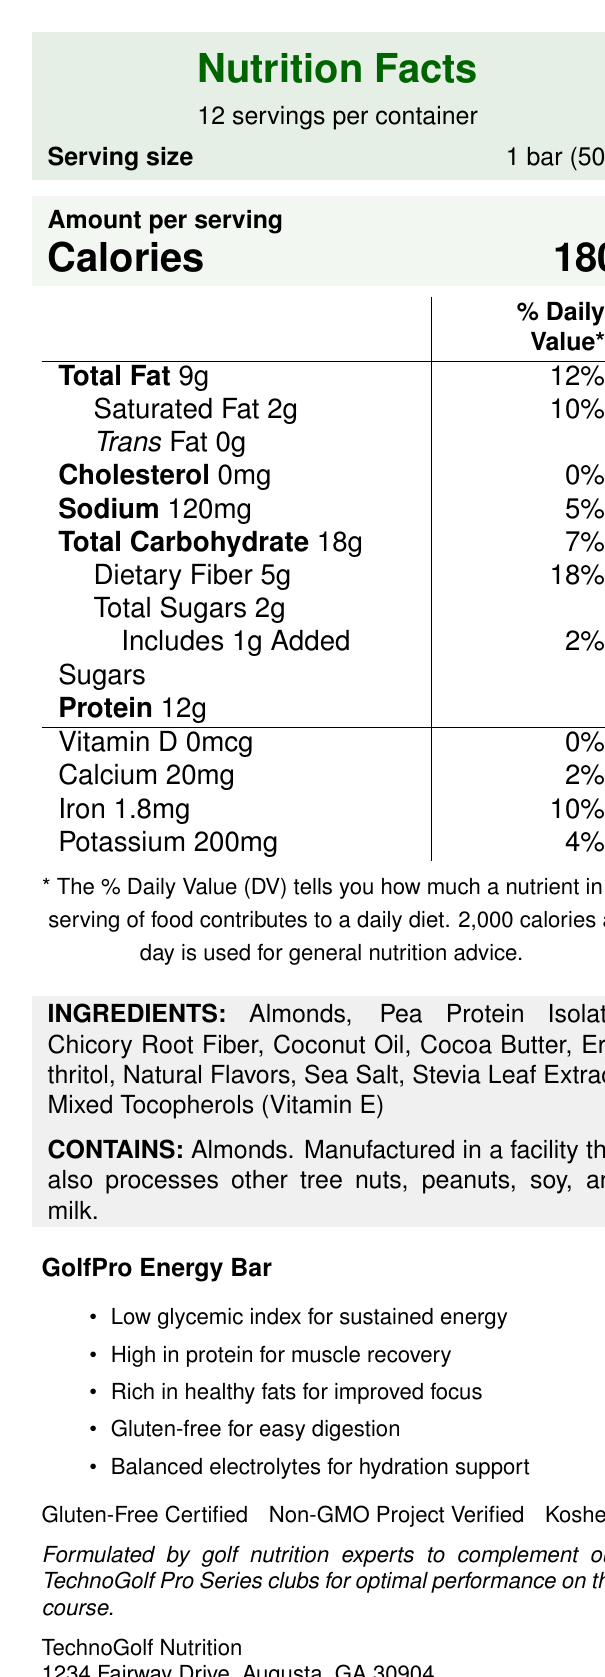What is the serving size of the GolfPro Energy Bar? The serving size is stated as "1 bar (50g)" under the Nutrition Facts.
Answer: 1 bar (50g) How many calories are in one serving of the GolfPro Energy Bar? The document specifies the calorie content per serving as 180.
Answer: 180 What percentage of the Daily Value is the total fat content per serving? The document states that the total fat content per serving is 12% of the Daily Value.
Answer: 12% Which ingredient provides dietary fiber in the GolfPro Energy Bar? Chicory Root Fiber is listed among the ingredients and is known for its high fiber content.
Answer: Chicory Root Fiber How much protein does one serving of the GolfPro Energy Bar contain? The document specifies that each serving contains 12g of protein.
Answer: 12g What is the primary benefit of this snack bar for golfers according to the performance features listed? The listed performance features highlight that it has a low glycemic index for sustained energy among other benefits.
Answer: Low glycemic index for sustained energy Which certification does the GolfPro Energy Bar have? A. Organic B. Gluten-Free C. Vegan D. Fair Trade The document indicates that the GolfPro Energy Bar is "Gluten-Free Certified," among other certifications.
Answer: B. Gluten-Free What are the amounts of Vitamin D and Calcium per serving? A. 0mcg and 20mg B. 0mcg and 50mg C. 2mcg and 100mg D. 10mcg and 200mg The document states that the amounts of Vitamin D and Calcium per serving are 0mcg and 20mg, respectively.
Answer: A. 0mcg and 20mg Is the GolfPro Energy Bar gluten-free? The document mentions that the bar is "Gluten-Free Certified."
Answer: Yes Describe the main idea of the document. The description captures the key elements of the document, including nutritional facts, ingredients, allergen information, performance features, and certifications.
Answer: The document provides nutritional information, ingredients, allergy information, and performance features of the GolfPro Energy Bar. It highlights that the bar is low-carb, gluten-free, and formulated to enhance golf performance. It is certified Gluten-Free, Non-GMO, and Kosher. How much added sugar is in one serving of the GolfPro Energy Bar? The document specifies that there is 1g of added sugars per serving.
Answer: 1g List two key nutrients for muscle recovery present in the GolfPro Energy Bar. The document lists protein (12g per serving) as key for muscle recovery, and calcium, although minimal, is also essential for muscle function.
Answer: Protein, Calcium Who manufactures the GolfPro Energy Bar, and where are they located? The manufacturer's information is provided at the end of the document.
Answer: TechnoGolf Nutrition, 1234 Fairway Drive, Augusta, GA 30904 What is the function of Mixed Tocopherols in the ingredient list? The function of Mixed Tocopherols is not explicitly mentioned in the document, therefore, we can't determine its function based on the provided visual information.
Answer: Not enough information 